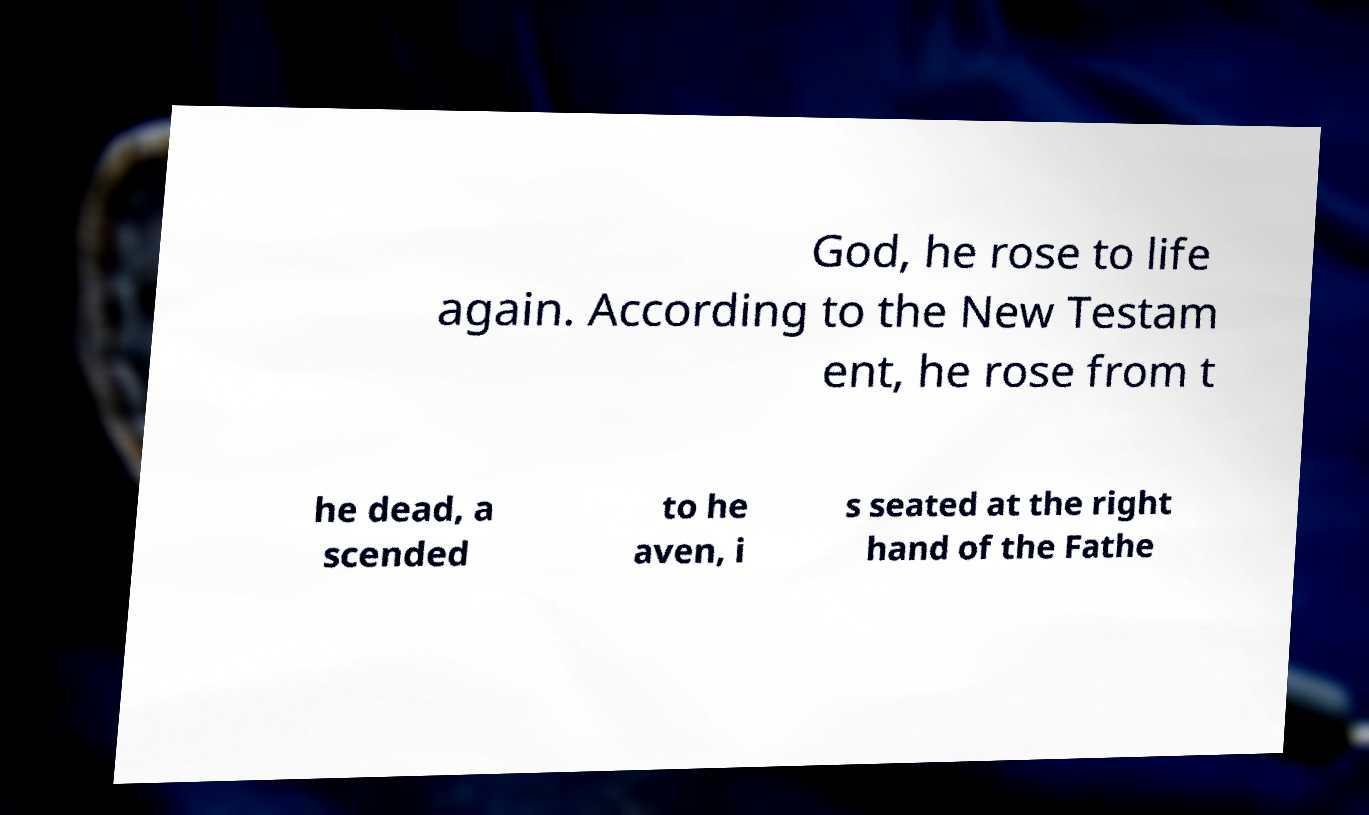For documentation purposes, I need the text within this image transcribed. Could you provide that? God, he rose to life again. According to the New Testam ent, he rose from t he dead, a scended to he aven, i s seated at the right hand of the Fathe 